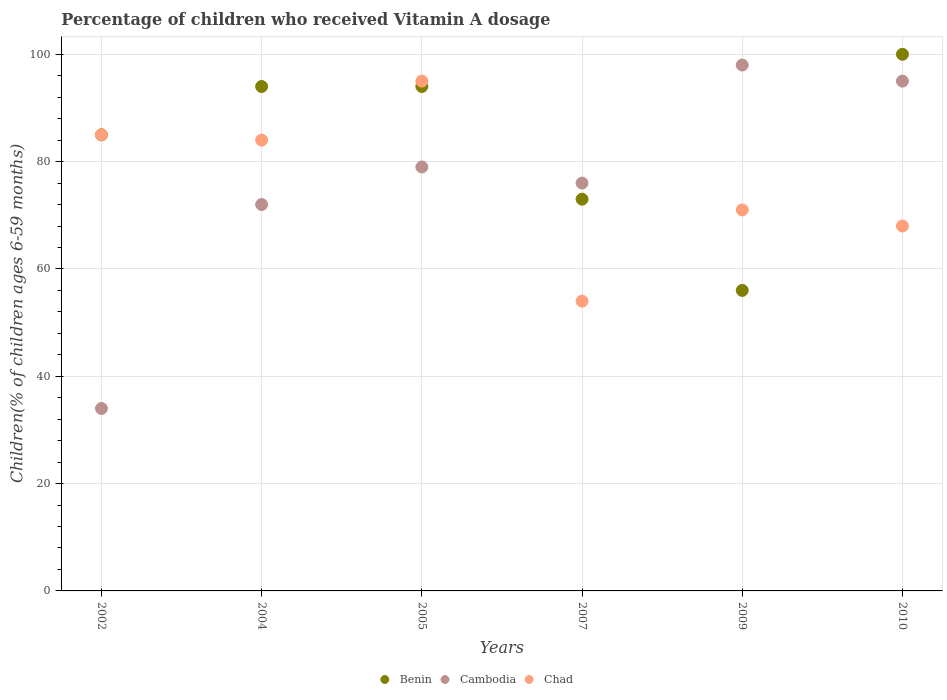Is the number of dotlines equal to the number of legend labels?
Make the answer very short. Yes. Across all years, what is the maximum percentage of children who received Vitamin A dosage in Cambodia?
Your answer should be compact. 98. Across all years, what is the minimum percentage of children who received Vitamin A dosage in Chad?
Your answer should be very brief. 54. In which year was the percentage of children who received Vitamin A dosage in Cambodia maximum?
Provide a succinct answer. 2009. What is the total percentage of children who received Vitamin A dosage in Benin in the graph?
Your answer should be very brief. 502. What is the difference between the percentage of children who received Vitamin A dosage in Chad in 2007 and the percentage of children who received Vitamin A dosage in Benin in 2009?
Keep it short and to the point. -2. What is the average percentage of children who received Vitamin A dosage in Chad per year?
Make the answer very short. 76.17. In the year 2010, what is the difference between the percentage of children who received Vitamin A dosage in Benin and percentage of children who received Vitamin A dosage in Chad?
Your response must be concise. 32. What is the ratio of the percentage of children who received Vitamin A dosage in Chad in 2005 to that in 2010?
Offer a very short reply. 1.4. Is the percentage of children who received Vitamin A dosage in Benin in 2005 less than that in 2010?
Ensure brevity in your answer.  Yes. In how many years, is the percentage of children who received Vitamin A dosage in Benin greater than the average percentage of children who received Vitamin A dosage in Benin taken over all years?
Your answer should be very brief. 4. Is it the case that in every year, the sum of the percentage of children who received Vitamin A dosage in Cambodia and percentage of children who received Vitamin A dosage in Chad  is greater than the percentage of children who received Vitamin A dosage in Benin?
Ensure brevity in your answer.  Yes. Is the percentage of children who received Vitamin A dosage in Benin strictly greater than the percentage of children who received Vitamin A dosage in Cambodia over the years?
Offer a terse response. No. Is the percentage of children who received Vitamin A dosage in Benin strictly less than the percentage of children who received Vitamin A dosage in Cambodia over the years?
Make the answer very short. No. How many years are there in the graph?
Your response must be concise. 6. Are the values on the major ticks of Y-axis written in scientific E-notation?
Your response must be concise. No. Does the graph contain grids?
Provide a succinct answer. Yes. What is the title of the graph?
Your response must be concise. Percentage of children who received Vitamin A dosage. Does "Nicaragua" appear as one of the legend labels in the graph?
Keep it short and to the point. No. What is the label or title of the Y-axis?
Provide a succinct answer. Children(% of children ages 6-59 months). What is the Children(% of children ages 6-59 months) of Benin in 2002?
Provide a short and direct response. 85. What is the Children(% of children ages 6-59 months) of Cambodia in 2002?
Keep it short and to the point. 34. What is the Children(% of children ages 6-59 months) of Chad in 2002?
Provide a succinct answer. 85. What is the Children(% of children ages 6-59 months) of Benin in 2004?
Your response must be concise. 94. What is the Children(% of children ages 6-59 months) in Cambodia in 2004?
Ensure brevity in your answer.  72. What is the Children(% of children ages 6-59 months) of Chad in 2004?
Your answer should be compact. 84. What is the Children(% of children ages 6-59 months) of Benin in 2005?
Ensure brevity in your answer.  94. What is the Children(% of children ages 6-59 months) in Cambodia in 2005?
Provide a short and direct response. 79. What is the Children(% of children ages 6-59 months) of Cambodia in 2007?
Your answer should be very brief. 76. What is the Children(% of children ages 6-59 months) of Benin in 2010?
Provide a succinct answer. 100. What is the Children(% of children ages 6-59 months) of Cambodia in 2010?
Give a very brief answer. 95. Across all years, what is the maximum Children(% of children ages 6-59 months) in Cambodia?
Ensure brevity in your answer.  98. Across all years, what is the minimum Children(% of children ages 6-59 months) of Chad?
Your response must be concise. 54. What is the total Children(% of children ages 6-59 months) in Benin in the graph?
Offer a terse response. 502. What is the total Children(% of children ages 6-59 months) in Cambodia in the graph?
Your answer should be compact. 454. What is the total Children(% of children ages 6-59 months) in Chad in the graph?
Make the answer very short. 457. What is the difference between the Children(% of children ages 6-59 months) of Cambodia in 2002 and that in 2004?
Provide a succinct answer. -38. What is the difference between the Children(% of children ages 6-59 months) of Chad in 2002 and that in 2004?
Make the answer very short. 1. What is the difference between the Children(% of children ages 6-59 months) of Benin in 2002 and that in 2005?
Offer a very short reply. -9. What is the difference between the Children(% of children ages 6-59 months) in Cambodia in 2002 and that in 2005?
Provide a succinct answer. -45. What is the difference between the Children(% of children ages 6-59 months) of Chad in 2002 and that in 2005?
Your answer should be very brief. -10. What is the difference between the Children(% of children ages 6-59 months) in Cambodia in 2002 and that in 2007?
Your response must be concise. -42. What is the difference between the Children(% of children ages 6-59 months) of Cambodia in 2002 and that in 2009?
Give a very brief answer. -64. What is the difference between the Children(% of children ages 6-59 months) of Chad in 2002 and that in 2009?
Your response must be concise. 14. What is the difference between the Children(% of children ages 6-59 months) in Cambodia in 2002 and that in 2010?
Your answer should be compact. -61. What is the difference between the Children(% of children ages 6-59 months) of Chad in 2002 and that in 2010?
Provide a succinct answer. 17. What is the difference between the Children(% of children ages 6-59 months) of Benin in 2004 and that in 2005?
Offer a very short reply. 0. What is the difference between the Children(% of children ages 6-59 months) of Cambodia in 2004 and that in 2005?
Provide a succinct answer. -7. What is the difference between the Children(% of children ages 6-59 months) of Chad in 2004 and that in 2005?
Provide a short and direct response. -11. What is the difference between the Children(% of children ages 6-59 months) in Cambodia in 2004 and that in 2009?
Offer a terse response. -26. What is the difference between the Children(% of children ages 6-59 months) of Cambodia in 2004 and that in 2010?
Provide a short and direct response. -23. What is the difference between the Children(% of children ages 6-59 months) of Benin in 2005 and that in 2007?
Offer a terse response. 21. What is the difference between the Children(% of children ages 6-59 months) in Chad in 2005 and that in 2007?
Offer a terse response. 41. What is the difference between the Children(% of children ages 6-59 months) of Chad in 2005 and that in 2009?
Make the answer very short. 24. What is the difference between the Children(% of children ages 6-59 months) in Cambodia in 2005 and that in 2010?
Give a very brief answer. -16. What is the difference between the Children(% of children ages 6-59 months) of Benin in 2007 and that in 2009?
Keep it short and to the point. 17. What is the difference between the Children(% of children ages 6-59 months) of Cambodia in 2007 and that in 2009?
Give a very brief answer. -22. What is the difference between the Children(% of children ages 6-59 months) of Chad in 2007 and that in 2009?
Keep it short and to the point. -17. What is the difference between the Children(% of children ages 6-59 months) in Benin in 2007 and that in 2010?
Your answer should be compact. -27. What is the difference between the Children(% of children ages 6-59 months) in Chad in 2007 and that in 2010?
Your answer should be very brief. -14. What is the difference between the Children(% of children ages 6-59 months) of Benin in 2009 and that in 2010?
Offer a terse response. -44. What is the difference between the Children(% of children ages 6-59 months) of Cambodia in 2002 and the Children(% of children ages 6-59 months) of Chad in 2004?
Provide a short and direct response. -50. What is the difference between the Children(% of children ages 6-59 months) of Cambodia in 2002 and the Children(% of children ages 6-59 months) of Chad in 2005?
Your response must be concise. -61. What is the difference between the Children(% of children ages 6-59 months) in Benin in 2002 and the Children(% of children ages 6-59 months) in Chad in 2007?
Your answer should be very brief. 31. What is the difference between the Children(% of children ages 6-59 months) of Cambodia in 2002 and the Children(% of children ages 6-59 months) of Chad in 2007?
Offer a very short reply. -20. What is the difference between the Children(% of children ages 6-59 months) in Cambodia in 2002 and the Children(% of children ages 6-59 months) in Chad in 2009?
Give a very brief answer. -37. What is the difference between the Children(% of children ages 6-59 months) of Benin in 2002 and the Children(% of children ages 6-59 months) of Cambodia in 2010?
Give a very brief answer. -10. What is the difference between the Children(% of children ages 6-59 months) of Cambodia in 2002 and the Children(% of children ages 6-59 months) of Chad in 2010?
Give a very brief answer. -34. What is the difference between the Children(% of children ages 6-59 months) in Benin in 2004 and the Children(% of children ages 6-59 months) in Cambodia in 2005?
Offer a very short reply. 15. What is the difference between the Children(% of children ages 6-59 months) of Benin in 2004 and the Children(% of children ages 6-59 months) of Chad in 2007?
Make the answer very short. 40. What is the difference between the Children(% of children ages 6-59 months) in Benin in 2004 and the Children(% of children ages 6-59 months) in Cambodia in 2009?
Provide a succinct answer. -4. What is the difference between the Children(% of children ages 6-59 months) in Benin in 2004 and the Children(% of children ages 6-59 months) in Chad in 2010?
Provide a succinct answer. 26. What is the difference between the Children(% of children ages 6-59 months) of Benin in 2005 and the Children(% of children ages 6-59 months) of Cambodia in 2007?
Offer a very short reply. 18. What is the difference between the Children(% of children ages 6-59 months) in Cambodia in 2005 and the Children(% of children ages 6-59 months) in Chad in 2007?
Provide a short and direct response. 25. What is the difference between the Children(% of children ages 6-59 months) in Benin in 2005 and the Children(% of children ages 6-59 months) in Cambodia in 2009?
Your answer should be compact. -4. What is the difference between the Children(% of children ages 6-59 months) of Cambodia in 2005 and the Children(% of children ages 6-59 months) of Chad in 2009?
Offer a very short reply. 8. What is the difference between the Children(% of children ages 6-59 months) of Benin in 2005 and the Children(% of children ages 6-59 months) of Chad in 2010?
Your answer should be compact. 26. What is the difference between the Children(% of children ages 6-59 months) of Cambodia in 2007 and the Children(% of children ages 6-59 months) of Chad in 2009?
Make the answer very short. 5. What is the difference between the Children(% of children ages 6-59 months) of Benin in 2007 and the Children(% of children ages 6-59 months) of Cambodia in 2010?
Give a very brief answer. -22. What is the difference between the Children(% of children ages 6-59 months) of Benin in 2009 and the Children(% of children ages 6-59 months) of Cambodia in 2010?
Provide a short and direct response. -39. What is the average Children(% of children ages 6-59 months) in Benin per year?
Offer a terse response. 83.67. What is the average Children(% of children ages 6-59 months) of Cambodia per year?
Provide a short and direct response. 75.67. What is the average Children(% of children ages 6-59 months) of Chad per year?
Make the answer very short. 76.17. In the year 2002, what is the difference between the Children(% of children ages 6-59 months) of Benin and Children(% of children ages 6-59 months) of Cambodia?
Offer a terse response. 51. In the year 2002, what is the difference between the Children(% of children ages 6-59 months) in Cambodia and Children(% of children ages 6-59 months) in Chad?
Make the answer very short. -51. In the year 2004, what is the difference between the Children(% of children ages 6-59 months) of Benin and Children(% of children ages 6-59 months) of Chad?
Offer a very short reply. 10. In the year 2004, what is the difference between the Children(% of children ages 6-59 months) in Cambodia and Children(% of children ages 6-59 months) in Chad?
Offer a terse response. -12. In the year 2007, what is the difference between the Children(% of children ages 6-59 months) in Benin and Children(% of children ages 6-59 months) in Cambodia?
Provide a short and direct response. -3. In the year 2007, what is the difference between the Children(% of children ages 6-59 months) in Benin and Children(% of children ages 6-59 months) in Chad?
Ensure brevity in your answer.  19. In the year 2009, what is the difference between the Children(% of children ages 6-59 months) in Benin and Children(% of children ages 6-59 months) in Cambodia?
Make the answer very short. -42. In the year 2009, what is the difference between the Children(% of children ages 6-59 months) of Cambodia and Children(% of children ages 6-59 months) of Chad?
Provide a succinct answer. 27. What is the ratio of the Children(% of children ages 6-59 months) of Benin in 2002 to that in 2004?
Your answer should be compact. 0.9. What is the ratio of the Children(% of children ages 6-59 months) in Cambodia in 2002 to that in 2004?
Keep it short and to the point. 0.47. What is the ratio of the Children(% of children ages 6-59 months) in Chad in 2002 to that in 2004?
Provide a succinct answer. 1.01. What is the ratio of the Children(% of children ages 6-59 months) of Benin in 2002 to that in 2005?
Offer a very short reply. 0.9. What is the ratio of the Children(% of children ages 6-59 months) of Cambodia in 2002 to that in 2005?
Your response must be concise. 0.43. What is the ratio of the Children(% of children ages 6-59 months) of Chad in 2002 to that in 2005?
Provide a succinct answer. 0.89. What is the ratio of the Children(% of children ages 6-59 months) in Benin in 2002 to that in 2007?
Ensure brevity in your answer.  1.16. What is the ratio of the Children(% of children ages 6-59 months) in Cambodia in 2002 to that in 2007?
Your answer should be compact. 0.45. What is the ratio of the Children(% of children ages 6-59 months) of Chad in 2002 to that in 2007?
Provide a short and direct response. 1.57. What is the ratio of the Children(% of children ages 6-59 months) in Benin in 2002 to that in 2009?
Provide a succinct answer. 1.52. What is the ratio of the Children(% of children ages 6-59 months) of Cambodia in 2002 to that in 2009?
Ensure brevity in your answer.  0.35. What is the ratio of the Children(% of children ages 6-59 months) of Chad in 2002 to that in 2009?
Give a very brief answer. 1.2. What is the ratio of the Children(% of children ages 6-59 months) of Benin in 2002 to that in 2010?
Give a very brief answer. 0.85. What is the ratio of the Children(% of children ages 6-59 months) in Cambodia in 2002 to that in 2010?
Offer a very short reply. 0.36. What is the ratio of the Children(% of children ages 6-59 months) of Chad in 2002 to that in 2010?
Keep it short and to the point. 1.25. What is the ratio of the Children(% of children ages 6-59 months) in Benin in 2004 to that in 2005?
Provide a succinct answer. 1. What is the ratio of the Children(% of children ages 6-59 months) of Cambodia in 2004 to that in 2005?
Your answer should be very brief. 0.91. What is the ratio of the Children(% of children ages 6-59 months) in Chad in 2004 to that in 2005?
Keep it short and to the point. 0.88. What is the ratio of the Children(% of children ages 6-59 months) in Benin in 2004 to that in 2007?
Your answer should be very brief. 1.29. What is the ratio of the Children(% of children ages 6-59 months) of Chad in 2004 to that in 2007?
Keep it short and to the point. 1.56. What is the ratio of the Children(% of children ages 6-59 months) in Benin in 2004 to that in 2009?
Give a very brief answer. 1.68. What is the ratio of the Children(% of children ages 6-59 months) of Cambodia in 2004 to that in 2009?
Your answer should be very brief. 0.73. What is the ratio of the Children(% of children ages 6-59 months) of Chad in 2004 to that in 2009?
Offer a terse response. 1.18. What is the ratio of the Children(% of children ages 6-59 months) in Benin in 2004 to that in 2010?
Keep it short and to the point. 0.94. What is the ratio of the Children(% of children ages 6-59 months) in Cambodia in 2004 to that in 2010?
Give a very brief answer. 0.76. What is the ratio of the Children(% of children ages 6-59 months) of Chad in 2004 to that in 2010?
Offer a terse response. 1.24. What is the ratio of the Children(% of children ages 6-59 months) in Benin in 2005 to that in 2007?
Ensure brevity in your answer.  1.29. What is the ratio of the Children(% of children ages 6-59 months) in Cambodia in 2005 to that in 2007?
Offer a very short reply. 1.04. What is the ratio of the Children(% of children ages 6-59 months) of Chad in 2005 to that in 2007?
Offer a very short reply. 1.76. What is the ratio of the Children(% of children ages 6-59 months) in Benin in 2005 to that in 2009?
Your response must be concise. 1.68. What is the ratio of the Children(% of children ages 6-59 months) of Cambodia in 2005 to that in 2009?
Keep it short and to the point. 0.81. What is the ratio of the Children(% of children ages 6-59 months) in Chad in 2005 to that in 2009?
Make the answer very short. 1.34. What is the ratio of the Children(% of children ages 6-59 months) of Benin in 2005 to that in 2010?
Ensure brevity in your answer.  0.94. What is the ratio of the Children(% of children ages 6-59 months) in Cambodia in 2005 to that in 2010?
Your response must be concise. 0.83. What is the ratio of the Children(% of children ages 6-59 months) of Chad in 2005 to that in 2010?
Ensure brevity in your answer.  1.4. What is the ratio of the Children(% of children ages 6-59 months) in Benin in 2007 to that in 2009?
Keep it short and to the point. 1.3. What is the ratio of the Children(% of children ages 6-59 months) of Cambodia in 2007 to that in 2009?
Your answer should be compact. 0.78. What is the ratio of the Children(% of children ages 6-59 months) of Chad in 2007 to that in 2009?
Your answer should be compact. 0.76. What is the ratio of the Children(% of children ages 6-59 months) of Benin in 2007 to that in 2010?
Your answer should be very brief. 0.73. What is the ratio of the Children(% of children ages 6-59 months) in Cambodia in 2007 to that in 2010?
Provide a succinct answer. 0.8. What is the ratio of the Children(% of children ages 6-59 months) of Chad in 2007 to that in 2010?
Make the answer very short. 0.79. What is the ratio of the Children(% of children ages 6-59 months) in Benin in 2009 to that in 2010?
Give a very brief answer. 0.56. What is the ratio of the Children(% of children ages 6-59 months) in Cambodia in 2009 to that in 2010?
Offer a very short reply. 1.03. What is the ratio of the Children(% of children ages 6-59 months) of Chad in 2009 to that in 2010?
Make the answer very short. 1.04. What is the difference between the highest and the second highest Children(% of children ages 6-59 months) in Cambodia?
Provide a short and direct response. 3. What is the difference between the highest and the lowest Children(% of children ages 6-59 months) in Benin?
Give a very brief answer. 44. 